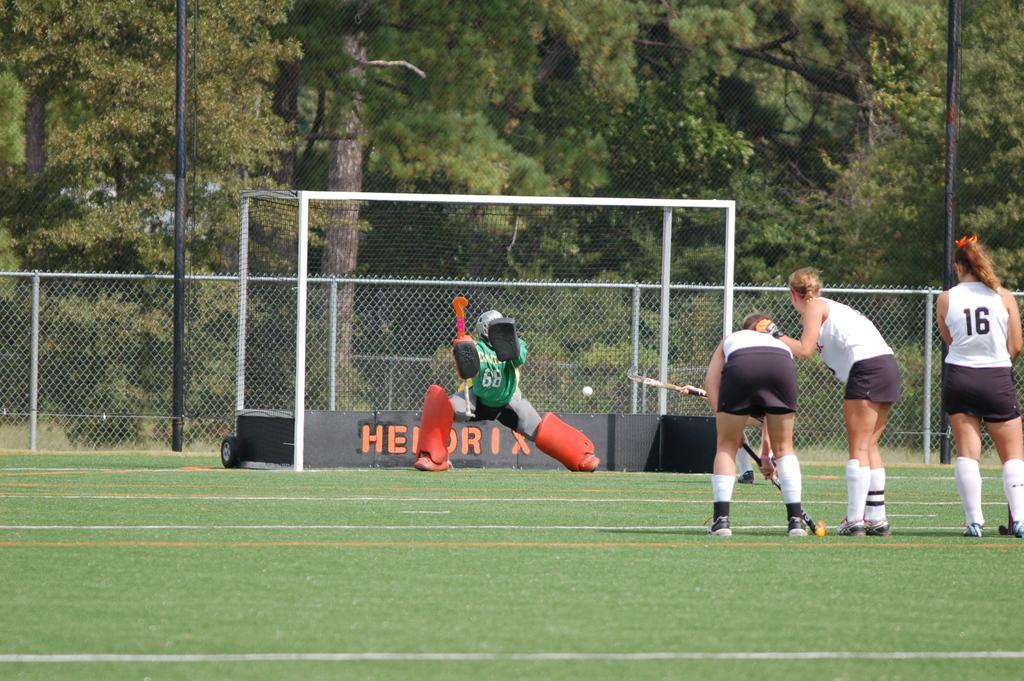<image>
Provide a brief description of the given image. a girl wearing the number 16 on her white shirt 